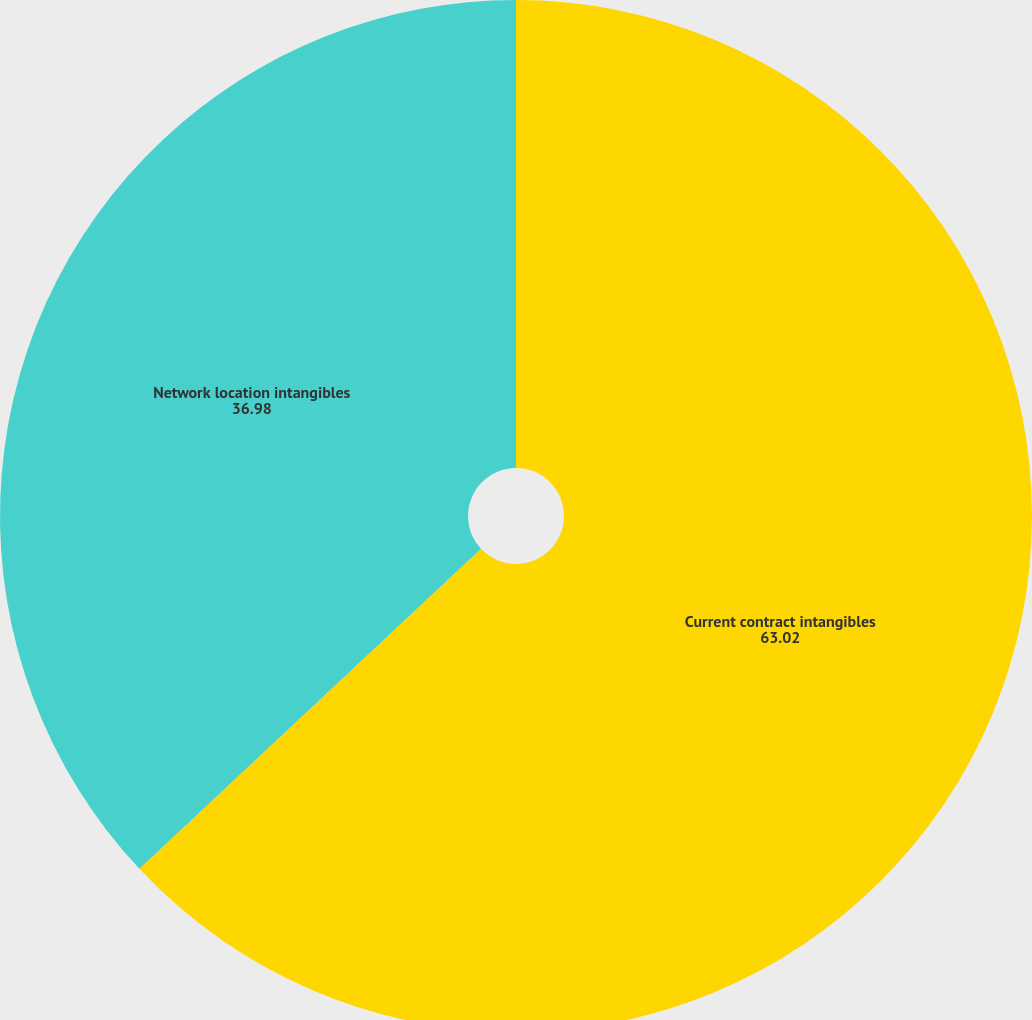Convert chart. <chart><loc_0><loc_0><loc_500><loc_500><pie_chart><fcel>Current contract intangibles<fcel>Network location intangibles<nl><fcel>63.02%<fcel>36.98%<nl></chart> 